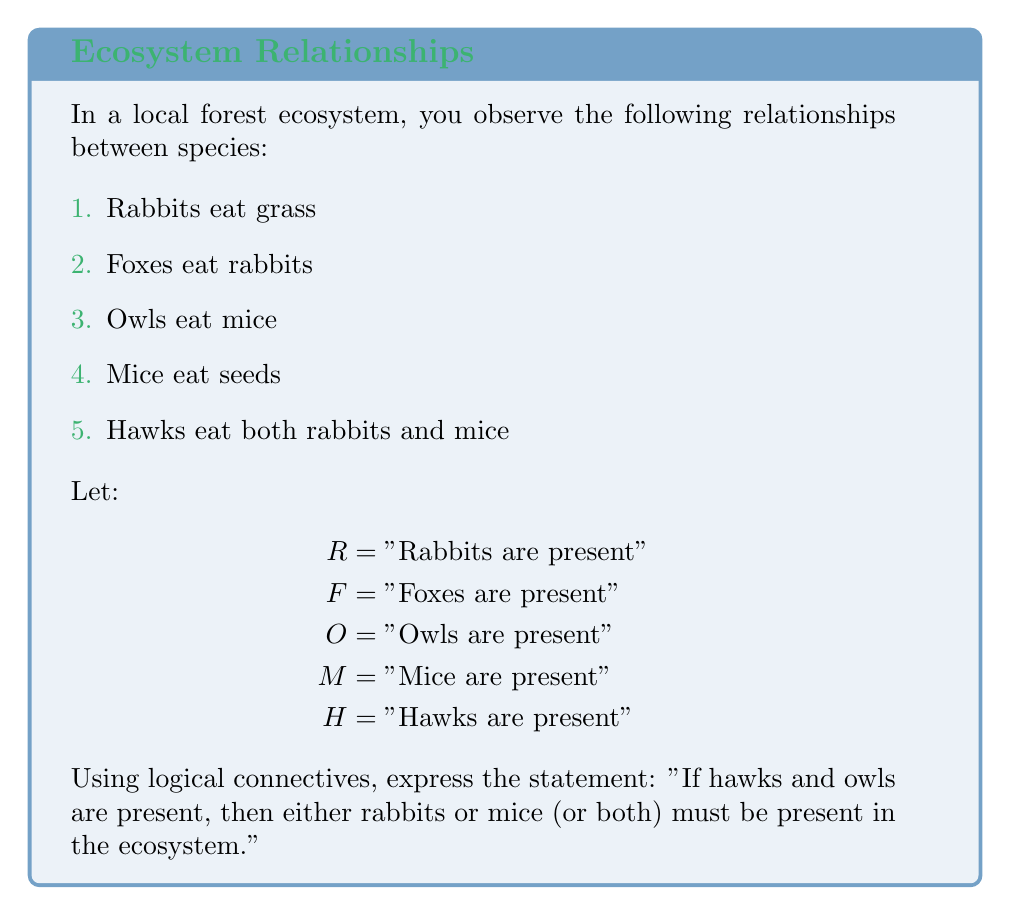What is the answer to this math problem? Let's break this down step-by-step:

1. We need to express "hawks and owls are present" using logical connectives:
   $H \land O$

2. We need to express "either rabbits or mice (or both) must be present":
   $R \lor M$

3. The statement is an implication, where the presence of hawks and owls implies the presence of rabbits or mice (or both). In logical notation, this is expressed as:

   $(H \land O) \rightarrow (R \lor M)$

4. This logical statement can be read as: "If hawks and owls are present, then rabbits or mice (or both) are present."

5. This makes ecological sense because:
   - Hawks eat both rabbits and mice
   - Owls eat mice
   So if both predators are present, at least one of their prey species must be present in the ecosystem.

The final logical expression that represents the given statement is:

$$(H \land O) \rightarrow (R \lor M)$$
Answer: $(H \land O) \rightarrow (R \lor M)$ 